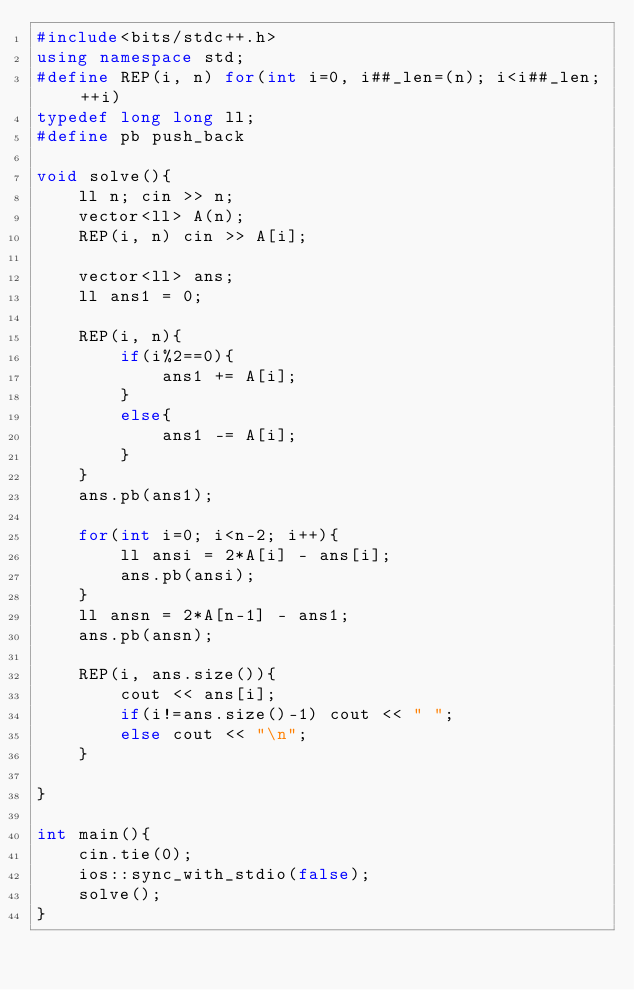<code> <loc_0><loc_0><loc_500><loc_500><_C++_>#include<bits/stdc++.h>
using namespace std;
#define REP(i, n) for(int i=0, i##_len=(n); i<i##_len; ++i)
typedef long long ll;
#define pb push_back

void solve(){
    ll n; cin >> n;
    vector<ll> A(n);
    REP(i, n) cin >> A[i];

    vector<ll> ans;
    ll ans1 = 0;

    REP(i, n){
        if(i%2==0){
            ans1 += A[i];
        }
        else{
            ans1 -= A[i];
        }
    }
    ans.pb(ans1);

    for(int i=0; i<n-2; i++){
        ll ansi = 2*A[i] - ans[i];
        ans.pb(ansi);
    }
    ll ansn = 2*A[n-1] - ans1;
    ans.pb(ansn);

    REP(i, ans.size()){
        cout << ans[i];
        if(i!=ans.size()-1) cout << " ";
        else cout << "\n";
    }

}

int main(){
    cin.tie(0);
    ios::sync_with_stdio(false);
    solve();
}</code> 